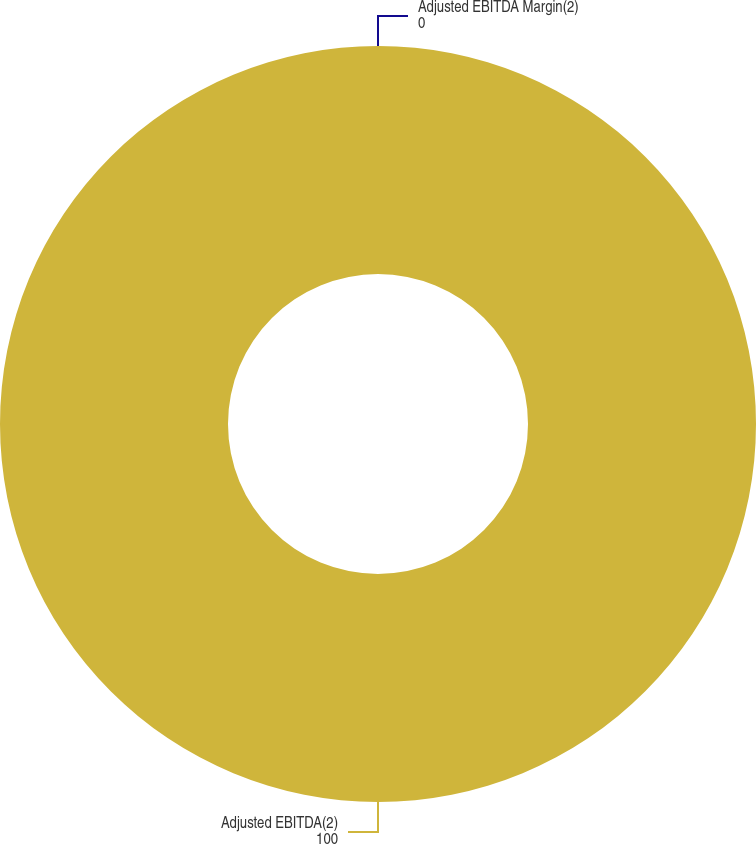Convert chart. <chart><loc_0><loc_0><loc_500><loc_500><pie_chart><fcel>Adjusted EBITDA(2)<fcel>Adjusted EBITDA Margin(2)<nl><fcel>100.0%<fcel>0.0%<nl></chart> 